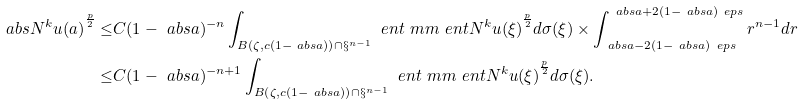<formula> <loc_0><loc_0><loc_500><loc_500>\ a b s { N ^ { k } u ( a ) } ^ { \frac { p } { 2 } } \leq & C ( 1 - \ a b s { a } ) ^ { - n } \int _ { B \left ( \zeta , c ( 1 - \ a b s { a } ) \right ) \cap \S ^ { n - 1 } } \ e n t { \ m m \ e n t { N ^ { k } u } ( \xi ) } ^ { \frac { p } { 2 } } d \sigma ( \xi ) \times \int _ { \ a b s { a } - 2 ( 1 - \ a b s { a } ) \ e p s } ^ { \ a b s { a } + 2 ( 1 - \ a b s { a } ) \ e p s } r ^ { n - 1 } d r \\ \leq & C ( 1 - \ a b s { a } ) ^ { - n + 1 } \int _ { B \left ( \zeta , c ( 1 - \ a b s { a } ) \right ) \cap \S ^ { n - 1 } } \ e n t { \ m m \ e n t { N ^ { k } u } ( \xi ) } ^ { \frac { p } { 2 } } d \sigma ( \xi ) .</formula> 